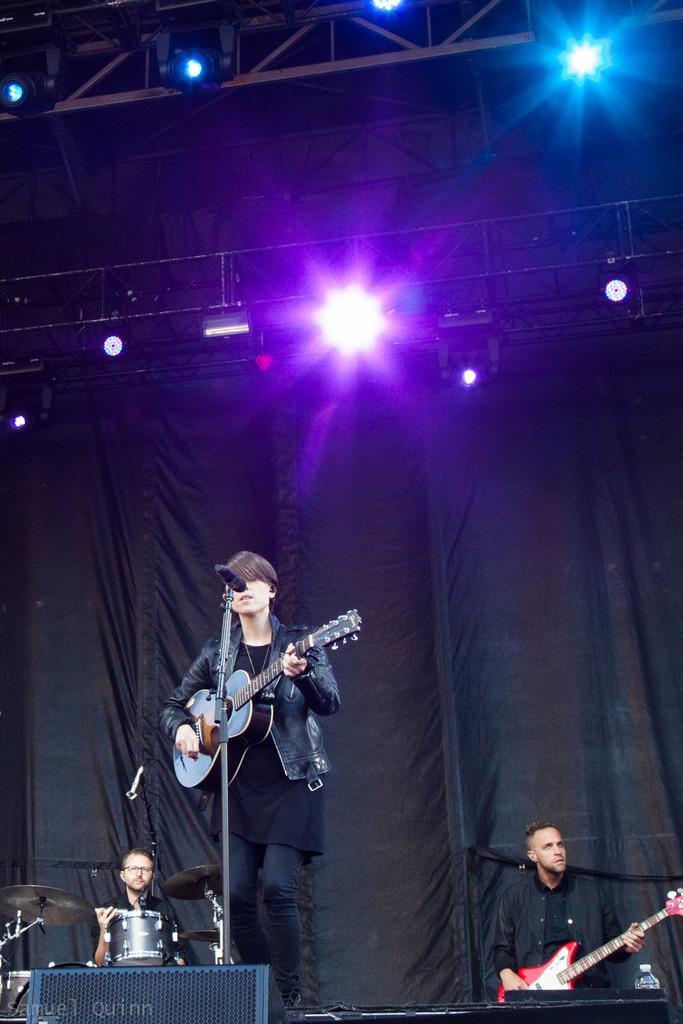In one or two sentences, can you explain what this image depicts? In this image we can see persons on the dais and holding musical instruments in their hands. In the background we can see electric lights, iron grills, curtains and mic. 